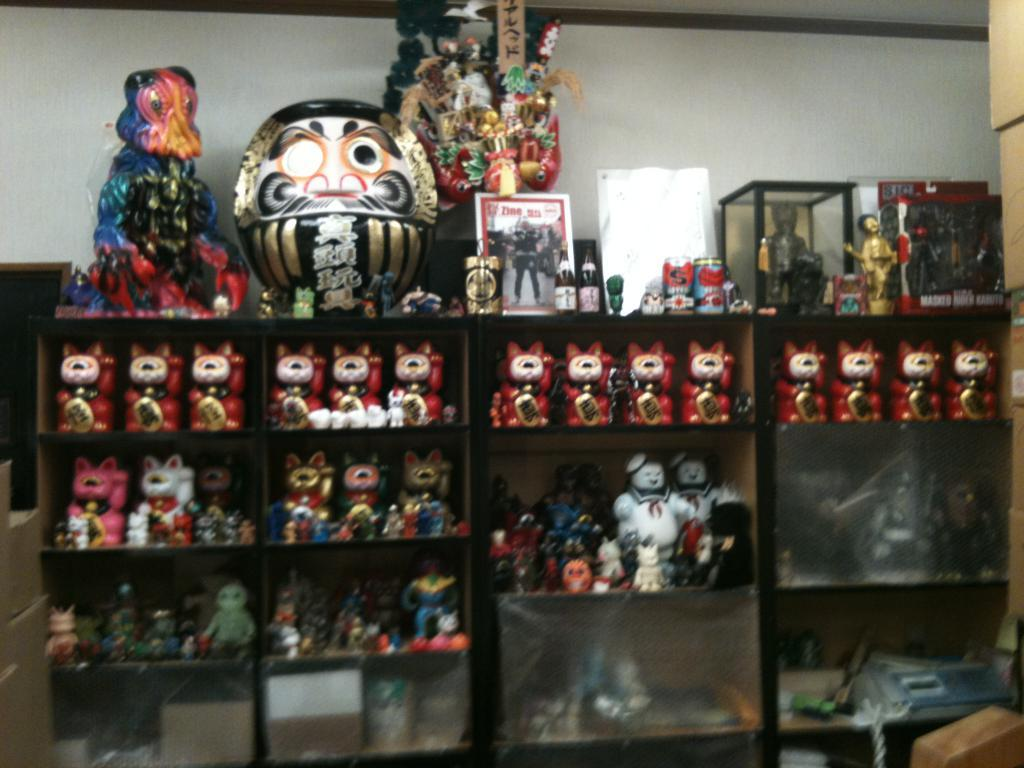What can be seen in the image? There are many toys in the image. Where are the toys located? The toys are on a shelf. What else is visible in the image besides the toys? There is a wall visible in the image. How many cakes are on the page in the image? There are no cakes or pages present in the image; it features toys on a shelf and a wall. 